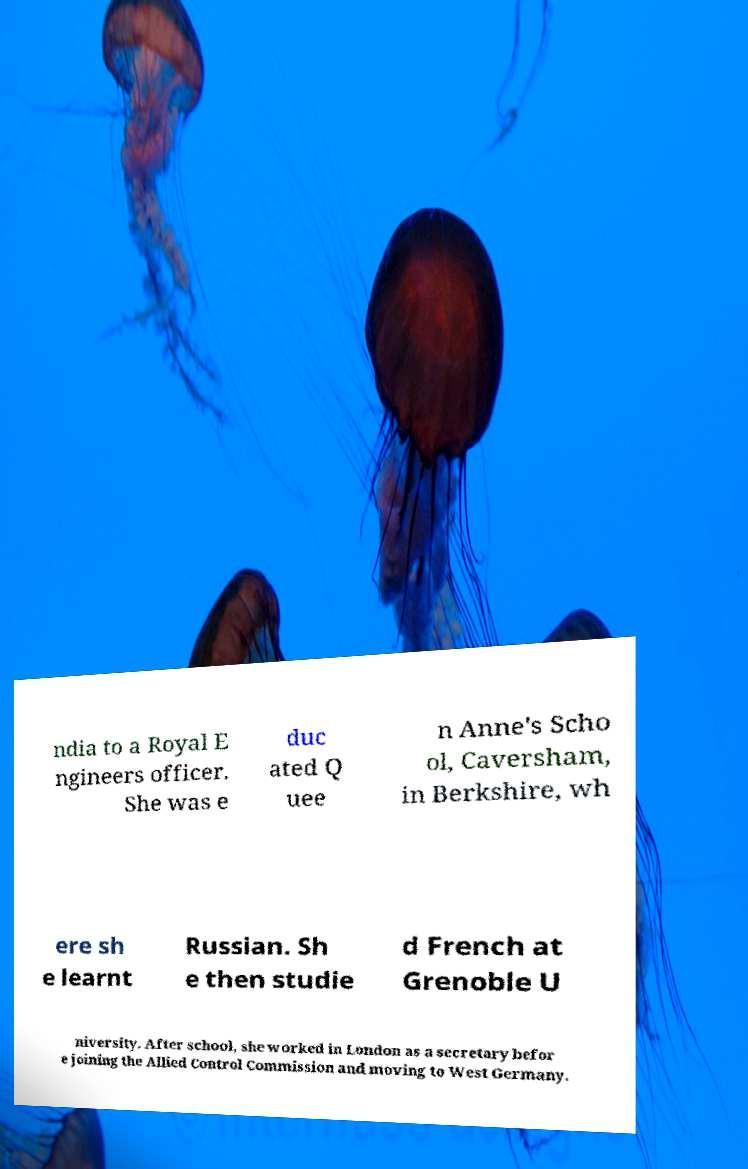What messages or text are displayed in this image? I need them in a readable, typed format. ndia to a Royal E ngineers officer. She was e duc ated Q uee n Anne's Scho ol, Caversham, in Berkshire, wh ere sh e learnt Russian. Sh e then studie d French at Grenoble U niversity. After school, she worked in London as a secretary befor e joining the Allied Control Commission and moving to West Germany. 